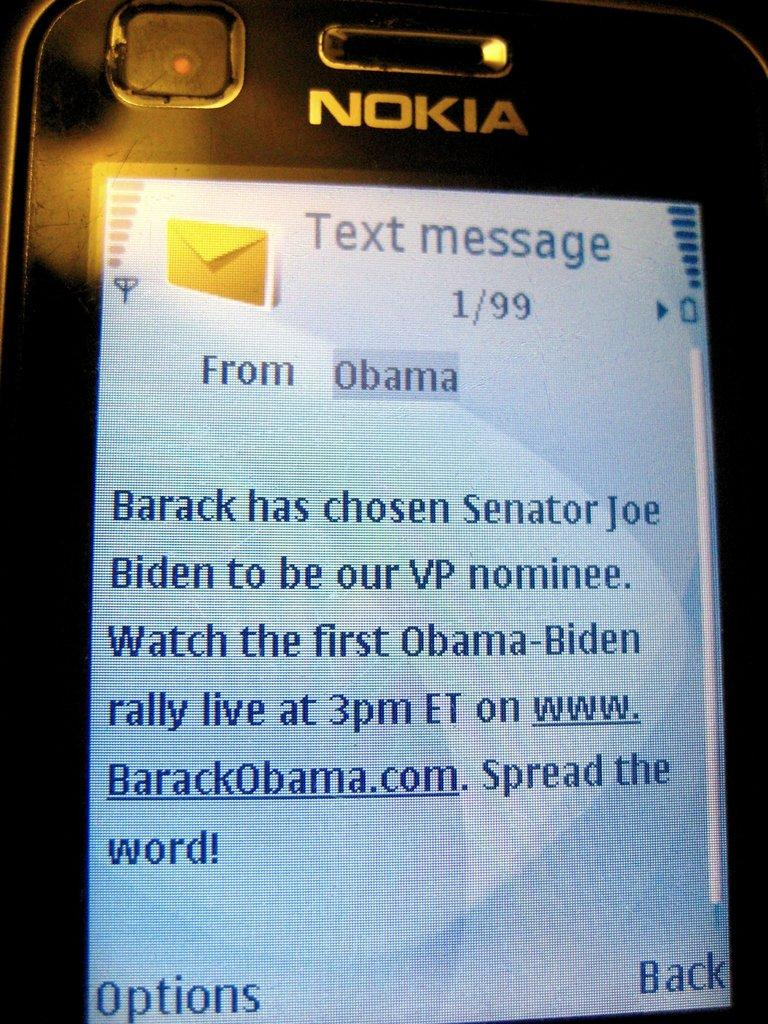What is the main subject of the image? The main subject of the image is a mobile phone screen. Can you describe the content of the mobile phone screen? Unfortunately, the content of the mobile phone screen cannot be determined from the image alone. Are there any fairies visible on the mobile phone screen in the image? There is no indication of fairies or any other specific content on the mobile phone screen in the image. 